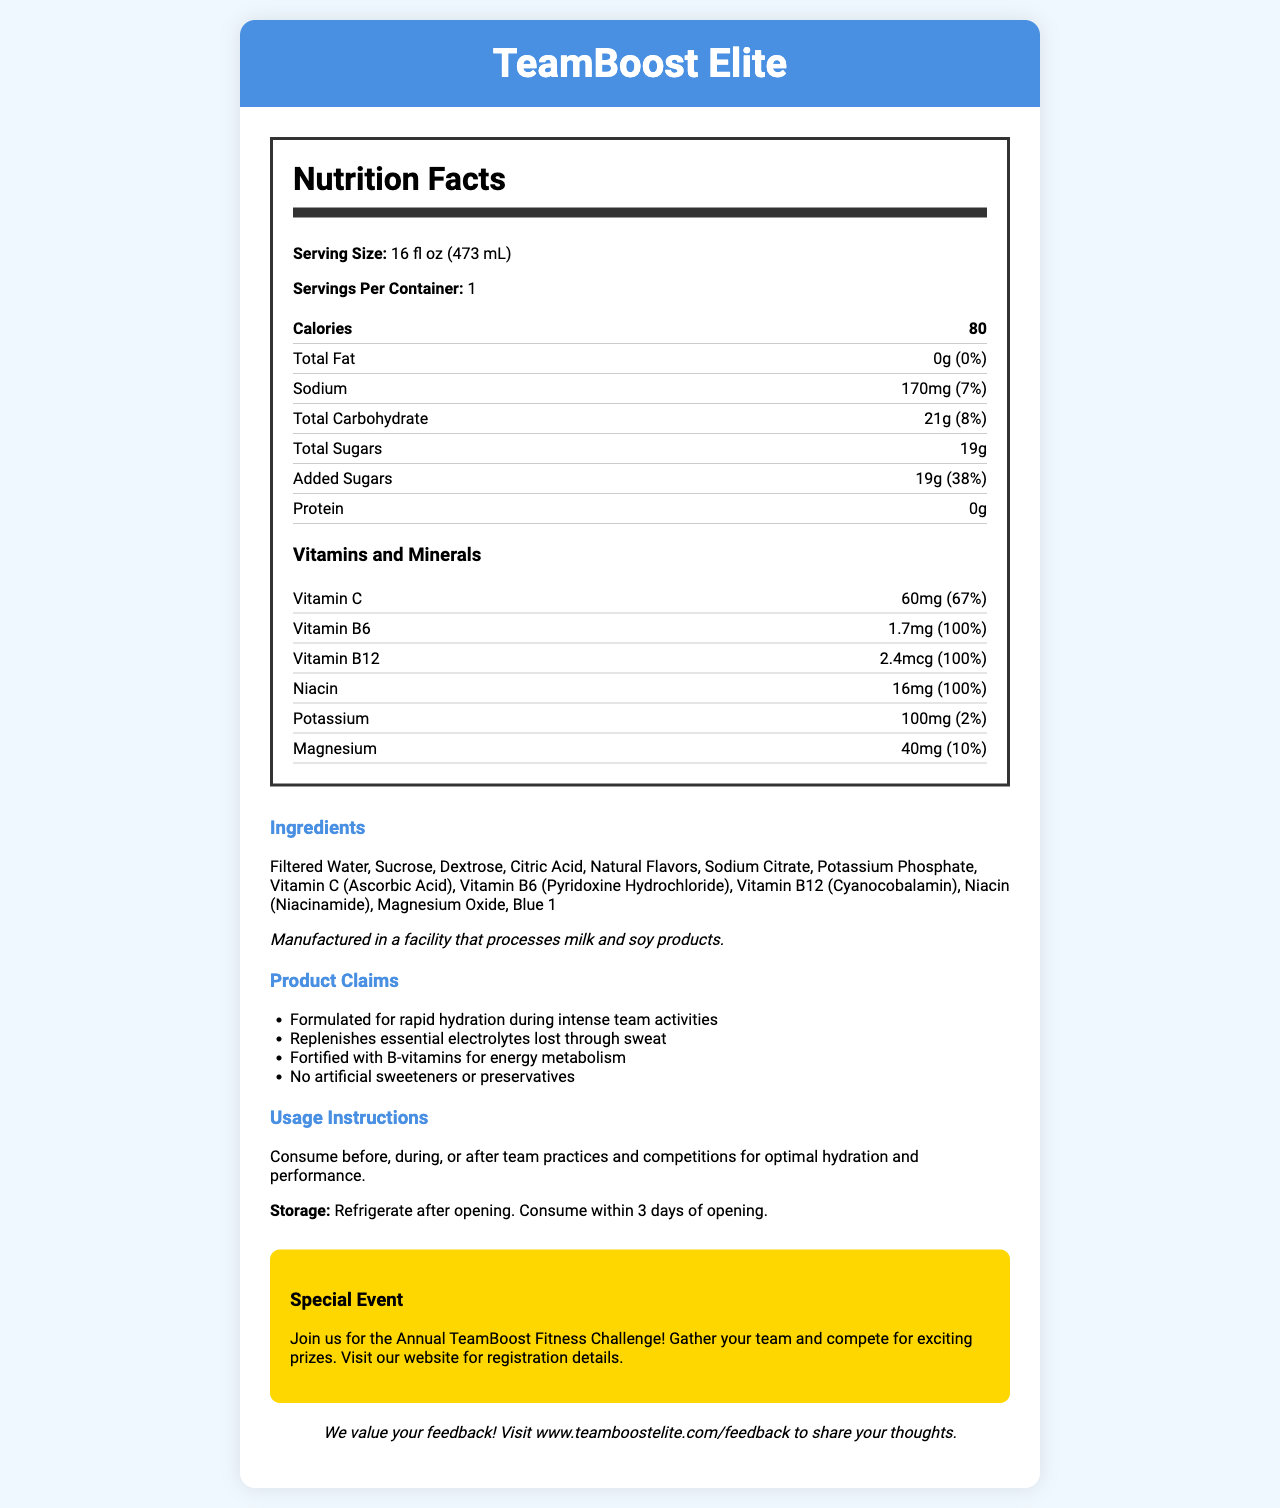What is the serving size of TeamBoost Elite? The serving size is explicitly mentioned at the beginning of the nutrition label.
Answer: 16 fl oz (473 mL) How many calories are in one serving of TeamBoost Elite? The number of calories is listed in the nutrition label section.
Answer: 80 What percentage of the daily value of sodium does one serving provide? The daily value percentage for sodium is provided next to the sodium amount.
Answer: 7% How many grams of total sugars are in one serving? The total sugars are clearly indicated in the nutrition label.
Answer: 19g What are the main ingredients in TeamBoost Elite? The ingredients are listed in the ingredients section.
Answer: Filtered Water, Sucrose, Dextrose, Citric Acid, Natural Flavors, Sodium Citrate, Potassium Phosphate, Vitamin C (Ascorbic Acid), Vitamin B6 (Pyridoxine Hydrochloride), Vitamin B12 (Cyanocobalamin), Niacin (Niacinamide), Magnesium Oxide, Blue 1 Which vitamin provides 100% of the daily value per serving? A. Vitamin C B. Vitamin B6 C. Niacin D. Vitamin B12 Both Vitamin B6 (1.7mg) and Vitamin B12 (2.4mcg) provide 100% of the daily value per serving.
Answer: B and D What is the purpose of TeamBoost Elite according to its claims? A. Improve mental performance B. Rapid hydration during intense team activities C. Weight loss support D. Muscle gain The product claims state it is formulated for rapid hydration during intense team activities.
Answer: B Does TeamBoost Elite contain any artificial sweeteners or preservatives? One of the product claims mentions that it contains no artificial sweeteners or preservatives.
Answer: No Are there any allergens mentioned for TeamBoost Elite? The allergen information states it is manufactured in a facility that processes milk and soy products.
Answer: Yes Provide a summary of the document. The document details nutritional information, ingredients, product claims, and instructions for the sports drink TeamBoost Elite, emphasizing hydration and energy metabolism. It also highlights an event and feedback opportunities.
Answer: TeamBoost Elite is a vitamin-fortified sports drink designed for team activities that provides hydration, replenishes electrolytes, and supports energy metabolism with essential B-vitamins. It contains 80 calories per serving, has no fat or protein, and provides 19g of total sugars. The drink includes several vitamins and minerals, such as Vitamin C, Vitamin B6, Vitamin B12, Niacin, Potassium, and Magnesium. Ingredients include filtered water, sucrose, and various vitamins and electrolytes. It is free of artificial sweeteners or preservatives and has detailed usage and storage instructions. The document also promotes an event and provides a feedback link. How many milligrams of Vitamin C are in one serving? The nutrition label specifies that one serving contains 60mg of Vitamin C.
Answer: 60mg What is the main idea of the product claims section? This section focuses on the benefits and unique selling points of the product.
Answer: The product claims that TeamBoost Elite provides rapid hydration during intense activities, replenishes essential electrolytes, is fortified with B-vitamins for energy metabolism, and contains no artificial sweeteners or preservatives. Does TeamBoost Elite come in different sized containers? The document only specifies information about the 16 fl oz (473 mL) container and does not mention any other sizes.
Answer: Cannot be determined What should you do after opening a container of TeamBoost Elite? The storage instructions state to refrigerate after opening and consume within 3 days.
Answer: Refrigerate and consume within 3 days 